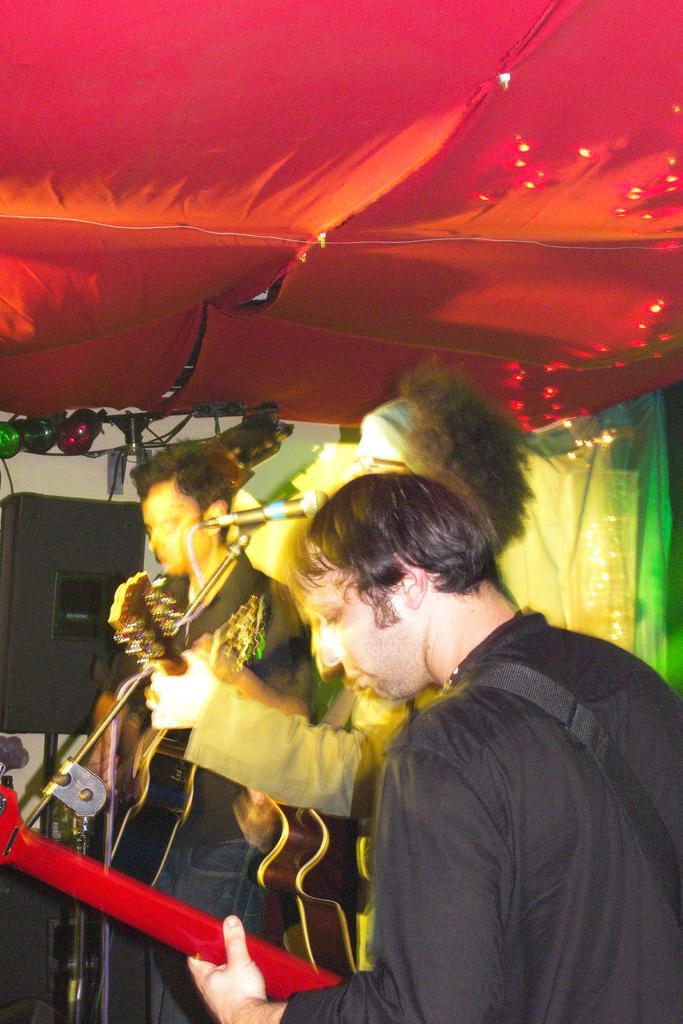Could you give a brief overview of what you see in this image? This is a blur image. I can see three people standing and holding musical instruments. One person in the center is holding a mike. At the top of the image I can see a red colored cloth rooftop and there are some lights. 